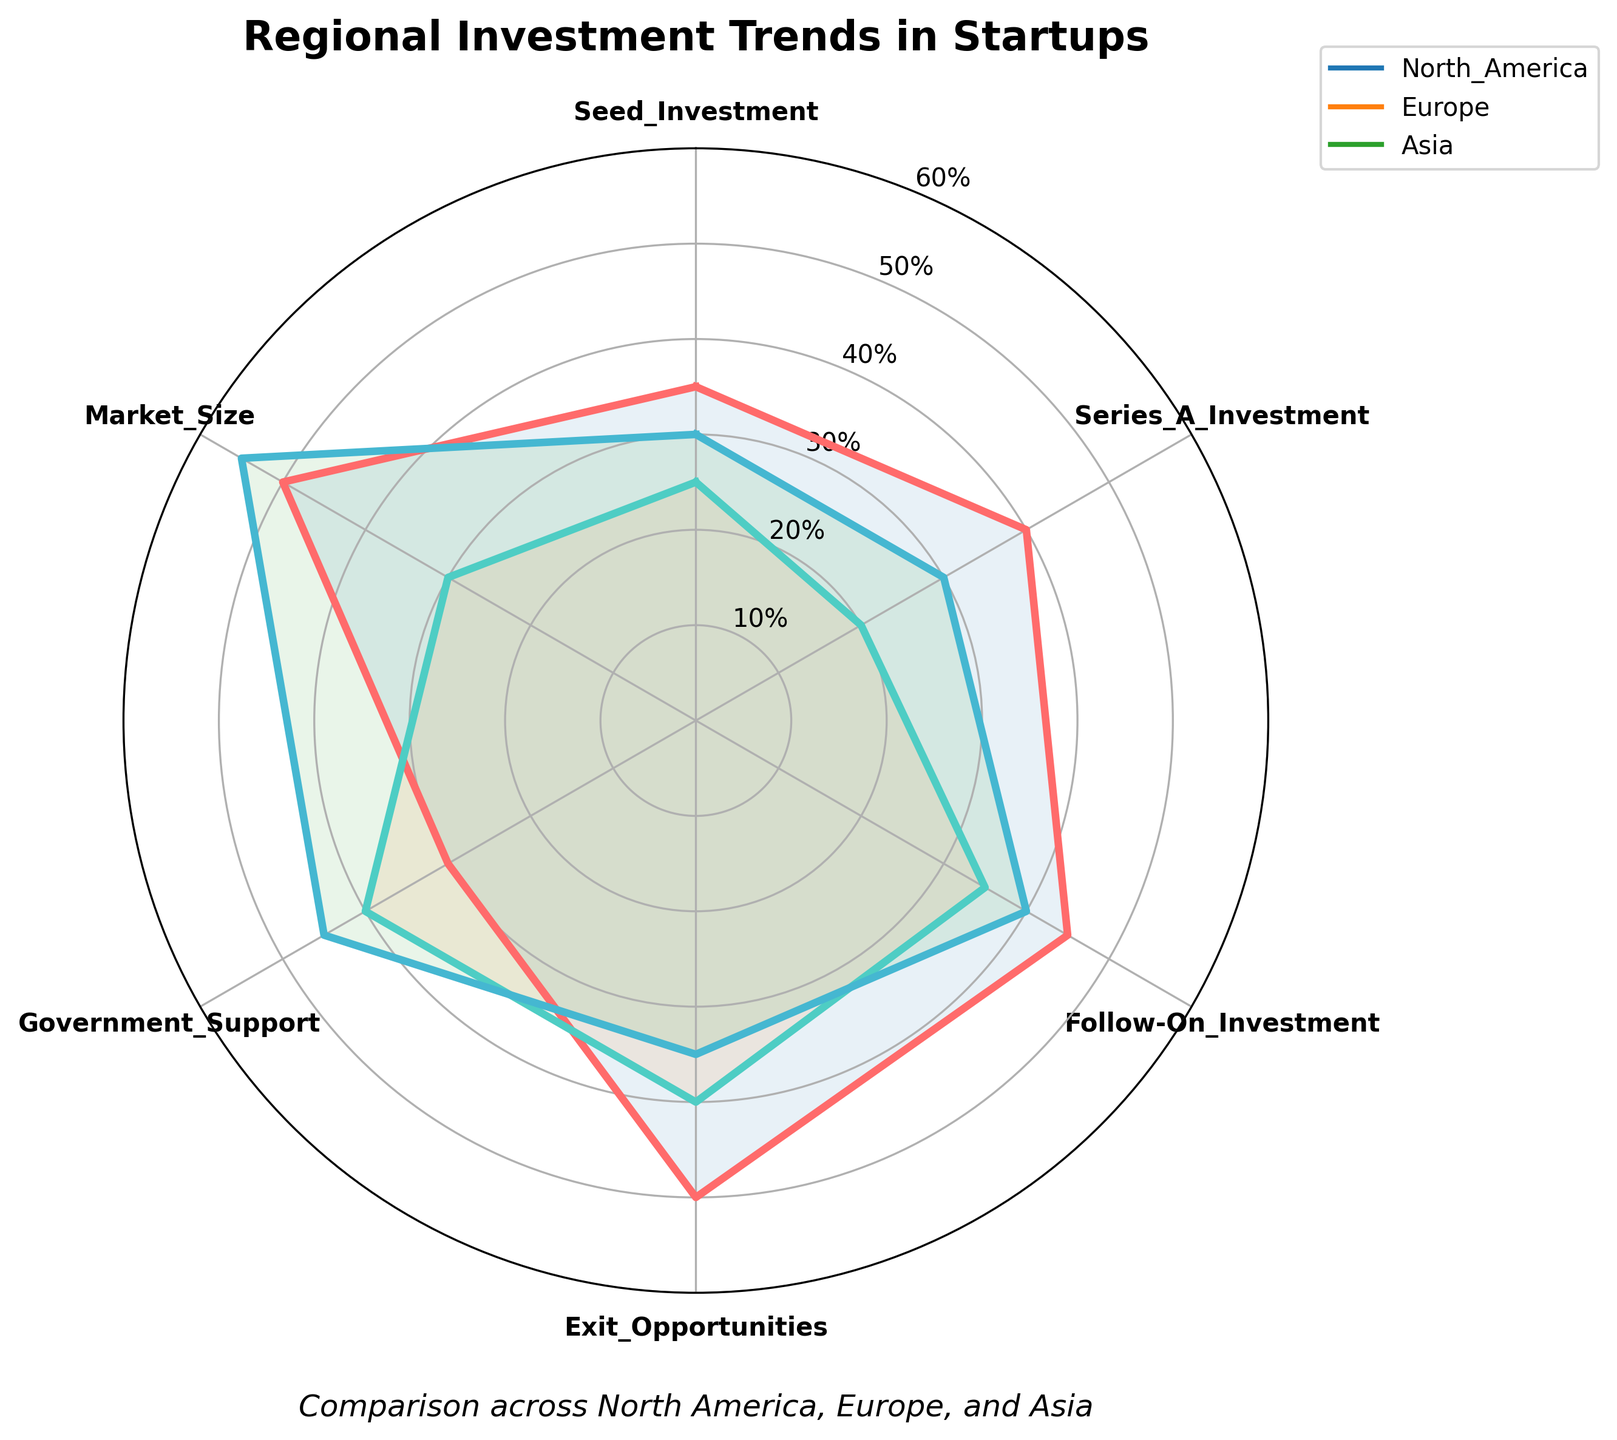How many regional groups are represented in the radar chart? The radar chart displays data for three regional groups: North America, Europe, and Asia. We can identify this directly by looking at the legend in the chart.
Answer: 3 Which region has the highest value for Market_Size? To find the region with the highest Market_Size, look at the end label corresponding to Market_Size and trace which plot line reaches the highest level. Asia's plot line extends the farthest, indicating the highest value.
Answer: Asia What is the difference in Government_Support values between Europe and North America? Government_Support values for Europe and North America can be read directly from the radar chart. Europe has a value of 40 and North America has a value of 30. The difference is obtained by subtracting the North American value from the European value. 40 - 30 = 10.
Answer: 10 Which investment aspect shows the smallest value for North America? By examining the different aspects for North America on the radar chart, the smallest value is identified by the shortest extension from the center under the North America label. Seed_Investment has the smallest value at 35.
Answer: Seed_Investment Among the regions, which has the highest average value across all investment aspects? To find the region with the highest average value, sum up the values for each region across all aspects and divide by the number of aspects (6). North America: (35+40+45+50+30+50)/6 = 41.67, Europe: (25+20+35+40+40+30)/6 = 31.67, Asia: (30+30+40+35+45+55)/6 = 39.17. North America has the highest average.
Answer: North America Which region shows the least variability in investment aspects? Variability can be assessed by the range (difference between maximum and minimum values). For North America, the values range from 30 to 50, for Europe from 20 to 40, and for Asia from 30 to 55. Europe has the smallest range of values (20). The least variability is shown by calculating the score ranges and comparing them.
Answer: Europe How does the Follow-On_Investment value in Asia compare to that in North America? Look at the Follow-On_Investment values for both Asia and North America on the radar chart. Asia has a value of 40 and North America has a value of 45. Asia's value is lower.
Answer: Lower Which investment aspect has the highest combined total across all regions? To find the combined total, add the values for each aspect across the three regions. The aspect with the highest sum is the one with the highest combined total. Seed_Investment: 35+25+30 = 90, Series_A_Investment: 40+20+30 = 90, Follow-On_Investment: 45+35+40 = 120, Exit_Opportunities: 50+40+35 = 125, Government_Support: 30+40+45 = 115, Market_Size: 50+30+55 = 135. Market_Size has the highest combined total.
Answer: Market_Size 